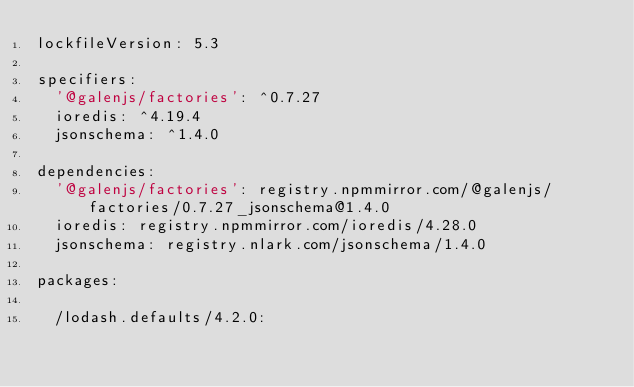Convert code to text. <code><loc_0><loc_0><loc_500><loc_500><_YAML_>lockfileVersion: 5.3

specifiers:
  '@galenjs/factories': ^0.7.27
  ioredis: ^4.19.4
  jsonschema: ^1.4.0

dependencies:
  '@galenjs/factories': registry.npmmirror.com/@galenjs/factories/0.7.27_jsonschema@1.4.0
  ioredis: registry.npmmirror.com/ioredis/4.28.0
  jsonschema: registry.nlark.com/jsonschema/1.4.0

packages:

  /lodash.defaults/4.2.0:</code> 